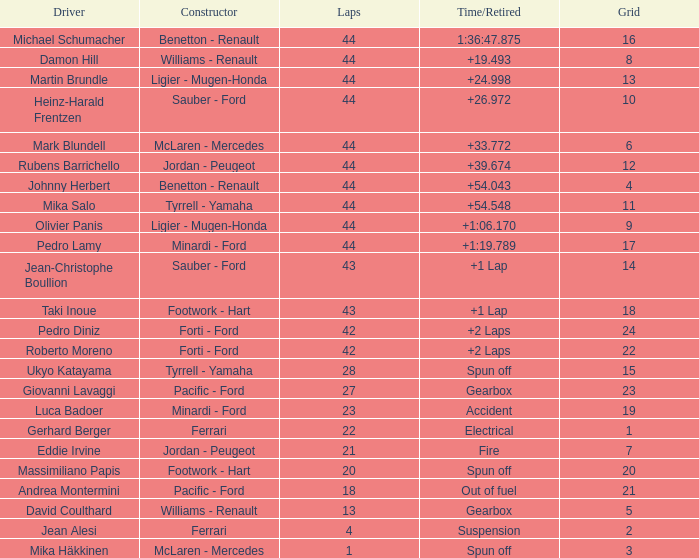Who built the car that ran out of fuel before 28 laps? Pacific - Ford. 